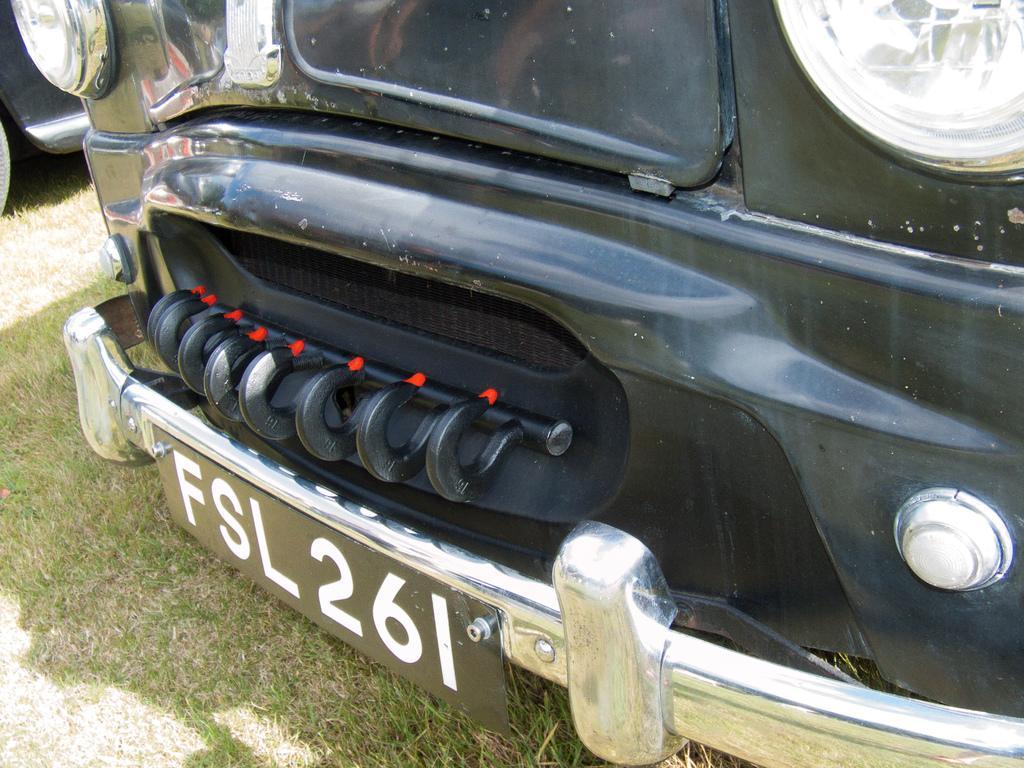Can you describe this image briefly? In this image I can see the vehicles on the grass. I can see the number plate to one of the vehicle. 